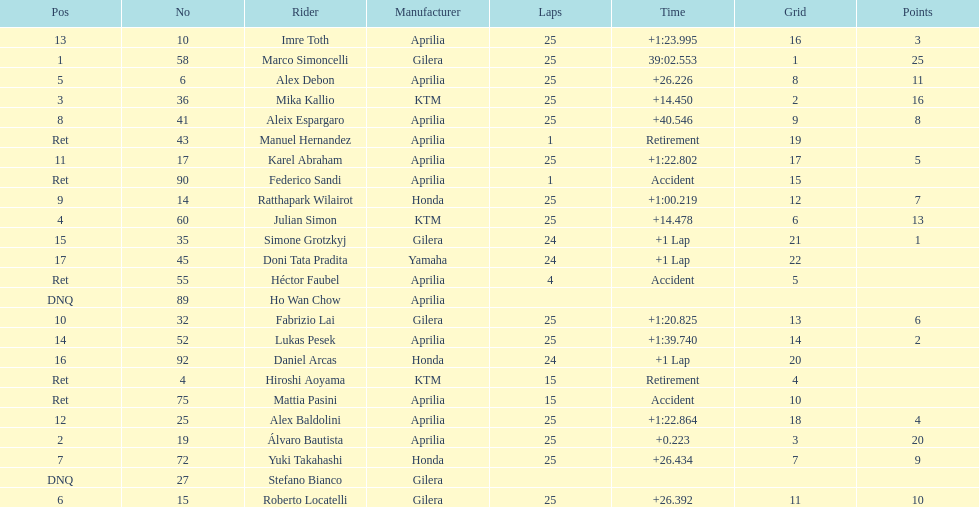Who are all the riders? Marco Simoncelli, Álvaro Bautista, Mika Kallio, Julian Simon, Alex Debon, Roberto Locatelli, Yuki Takahashi, Aleix Espargaro, Ratthapark Wilairot, Fabrizio Lai, Karel Abraham, Alex Baldolini, Imre Toth, Lukas Pesek, Simone Grotzkyj, Daniel Arcas, Doni Tata Pradita, Hiroshi Aoyama, Mattia Pasini, Héctor Faubel, Federico Sandi, Manuel Hernandez, Stefano Bianco, Ho Wan Chow. Which held rank 1? Marco Simoncelli. 